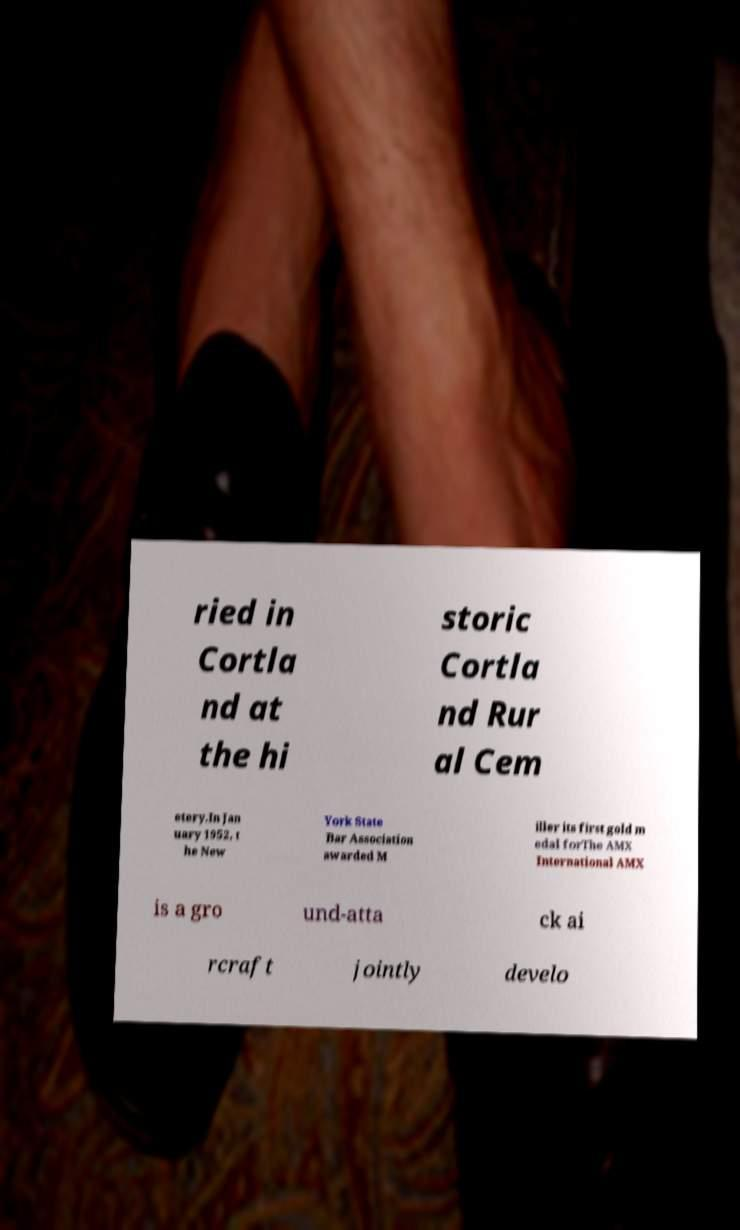Please identify and transcribe the text found in this image. ried in Cortla nd at the hi storic Cortla nd Rur al Cem etery.In Jan uary 1952, t he New York State Bar Association awarded M iller its first gold m edal forThe AMX International AMX is a gro und-atta ck ai rcraft jointly develo 